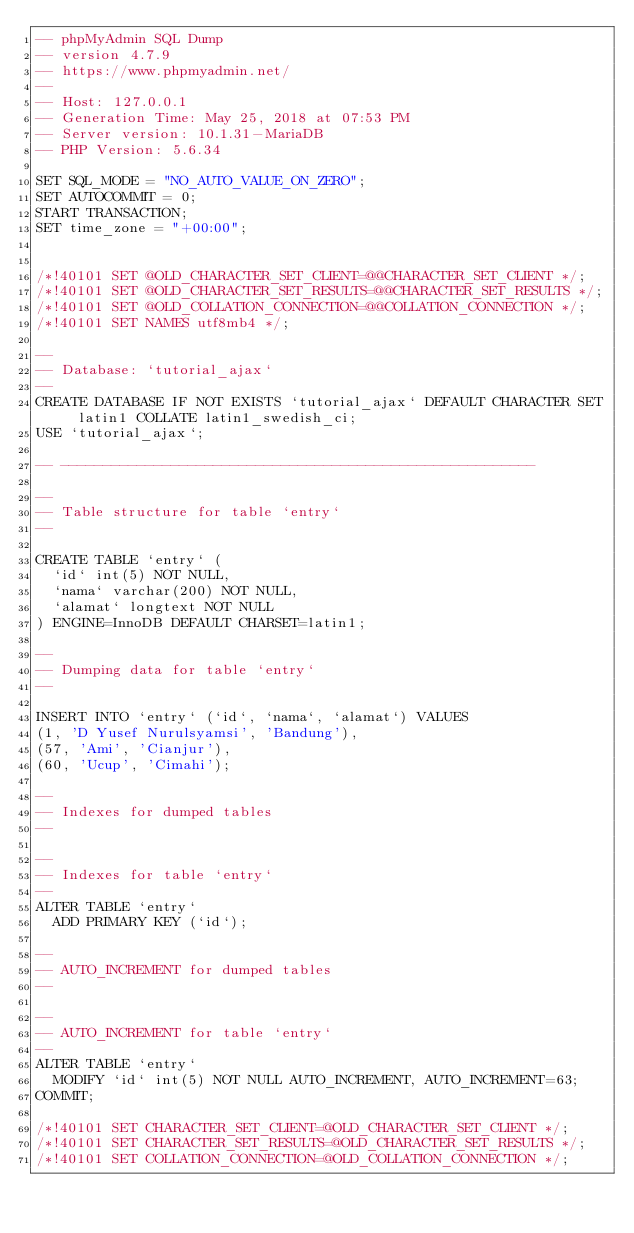Convert code to text. <code><loc_0><loc_0><loc_500><loc_500><_SQL_>-- phpMyAdmin SQL Dump
-- version 4.7.9
-- https://www.phpmyadmin.net/
--
-- Host: 127.0.0.1
-- Generation Time: May 25, 2018 at 07:53 PM
-- Server version: 10.1.31-MariaDB
-- PHP Version: 5.6.34

SET SQL_MODE = "NO_AUTO_VALUE_ON_ZERO";
SET AUTOCOMMIT = 0;
START TRANSACTION;
SET time_zone = "+00:00";


/*!40101 SET @OLD_CHARACTER_SET_CLIENT=@@CHARACTER_SET_CLIENT */;
/*!40101 SET @OLD_CHARACTER_SET_RESULTS=@@CHARACTER_SET_RESULTS */;
/*!40101 SET @OLD_COLLATION_CONNECTION=@@COLLATION_CONNECTION */;
/*!40101 SET NAMES utf8mb4 */;

--
-- Database: `tutorial_ajax`
--
CREATE DATABASE IF NOT EXISTS `tutorial_ajax` DEFAULT CHARACTER SET latin1 COLLATE latin1_swedish_ci;
USE `tutorial_ajax`;

-- --------------------------------------------------------

--
-- Table structure for table `entry`
--

CREATE TABLE `entry` (
  `id` int(5) NOT NULL,
  `nama` varchar(200) NOT NULL,
  `alamat` longtext NOT NULL
) ENGINE=InnoDB DEFAULT CHARSET=latin1;

--
-- Dumping data for table `entry`
--

INSERT INTO `entry` (`id`, `nama`, `alamat`) VALUES
(1, 'D Yusef Nurulsyamsi', 'Bandung'),
(57, 'Ami', 'Cianjur'),
(60, 'Ucup', 'Cimahi');

--
-- Indexes for dumped tables
--

--
-- Indexes for table `entry`
--
ALTER TABLE `entry`
  ADD PRIMARY KEY (`id`);

--
-- AUTO_INCREMENT for dumped tables
--

--
-- AUTO_INCREMENT for table `entry`
--
ALTER TABLE `entry`
  MODIFY `id` int(5) NOT NULL AUTO_INCREMENT, AUTO_INCREMENT=63;
COMMIT;

/*!40101 SET CHARACTER_SET_CLIENT=@OLD_CHARACTER_SET_CLIENT */;
/*!40101 SET CHARACTER_SET_RESULTS=@OLD_CHARACTER_SET_RESULTS */;
/*!40101 SET COLLATION_CONNECTION=@OLD_COLLATION_CONNECTION */;
</code> 